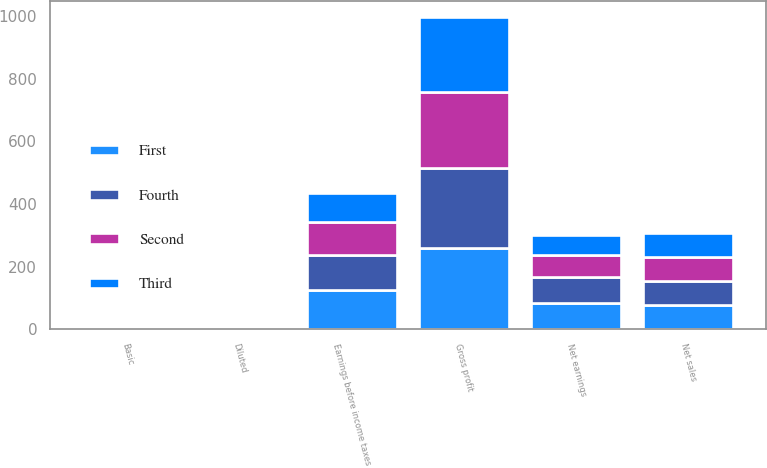Convert chart to OTSL. <chart><loc_0><loc_0><loc_500><loc_500><stacked_bar_chart><ecel><fcel>Net sales<fcel>Gross profit<fcel>Earnings before income taxes<fcel>Net earnings<fcel>Basic<fcel>Diluted<nl><fcel>Third<fcel>77<fcel>240.1<fcel>92.3<fcel>62.1<fcel>0.33<fcel>0.33<nl><fcel>Fourth<fcel>77<fcel>256.4<fcel>111.6<fcel>84.2<fcel>0.45<fcel>0.45<nl><fcel>First<fcel>77<fcel>258.6<fcel>125.1<fcel>84<fcel>0.45<fcel>0.45<nl><fcel>Second<fcel>77<fcel>243.3<fcel>105.8<fcel>70<fcel>0.38<fcel>0.38<nl></chart> 